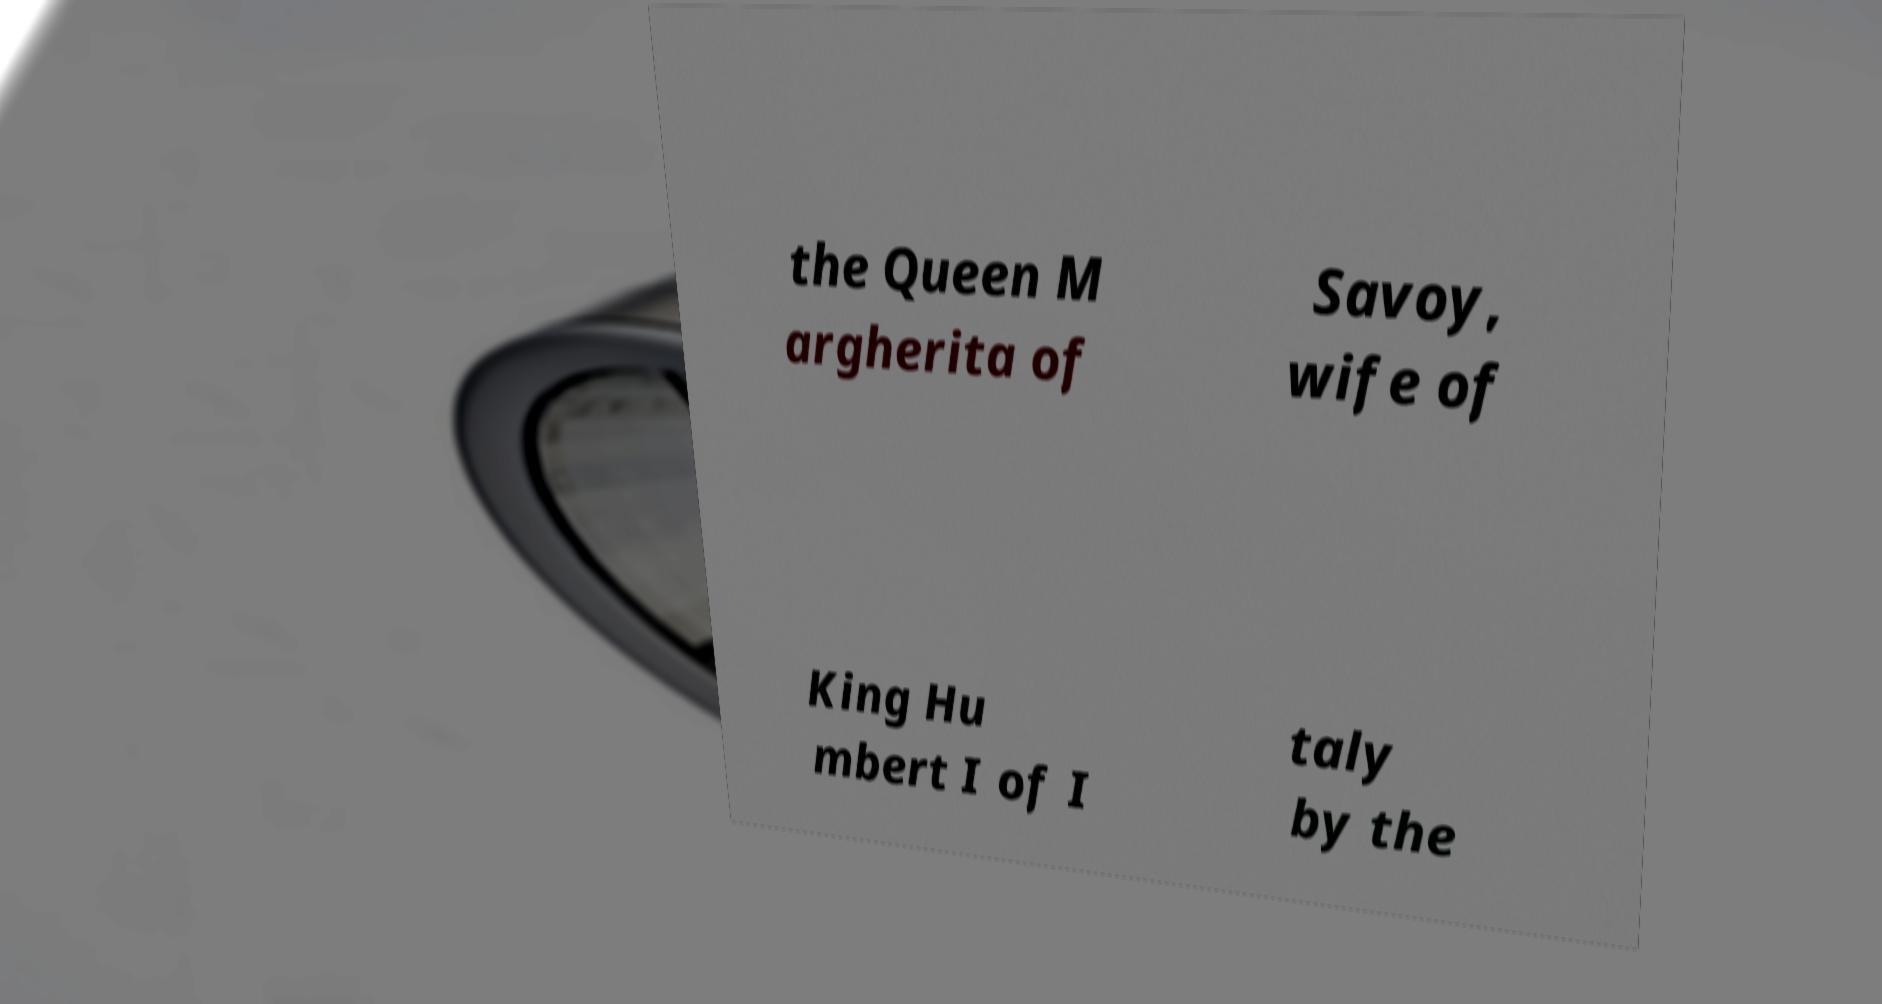Can you read and provide the text displayed in the image?This photo seems to have some interesting text. Can you extract and type it out for me? the Queen M argherita of Savoy, wife of King Hu mbert I of I taly by the 